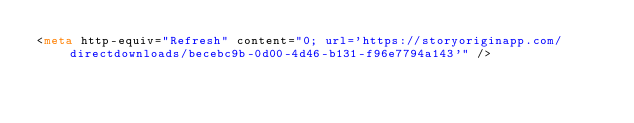<code> <loc_0><loc_0><loc_500><loc_500><_HTML_><meta http-equiv="Refresh" content="0; url='https://storyoriginapp.com/directdownloads/becebc9b-0d00-4d46-b131-f96e7794a143'" />
</code> 